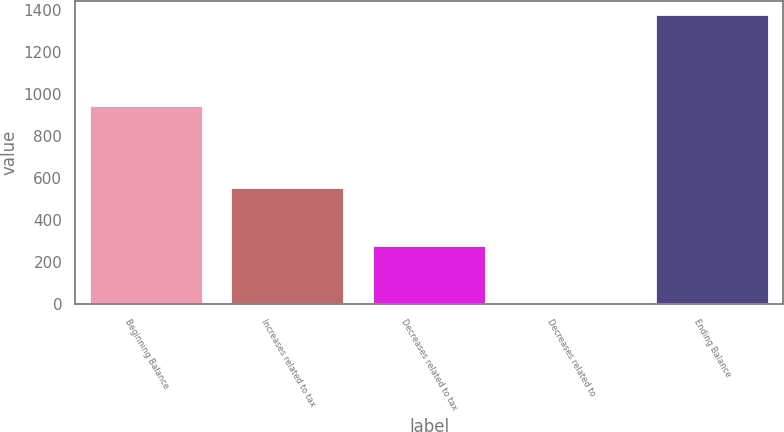<chart> <loc_0><loc_0><loc_500><loc_500><bar_chart><fcel>Beginning Balance<fcel>Increases related to tax<fcel>Decreases related to tax<fcel>Decreases related to<fcel>Ending Balance<nl><fcel>943<fcel>551.8<fcel>277.4<fcel>3<fcel>1375<nl></chart> 